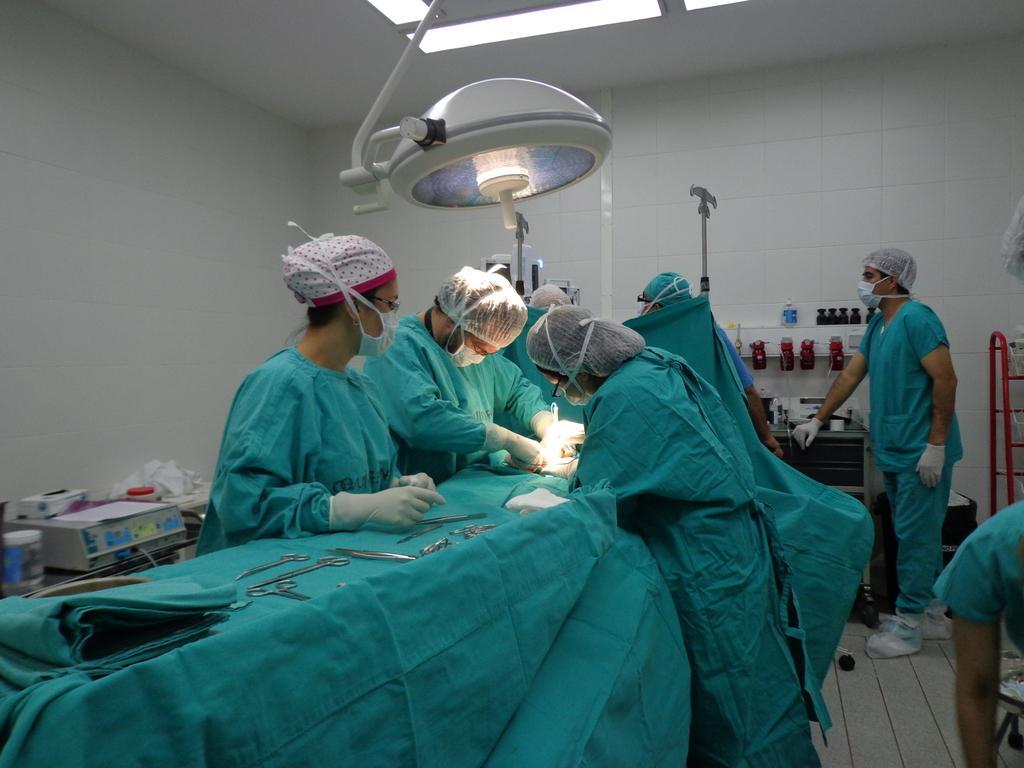How would you summarize this image in a sentence or two? This is the picture of a room in which there are some people wearing aprons, and doing something in front of the table on which there are some things and around there are some other things. 